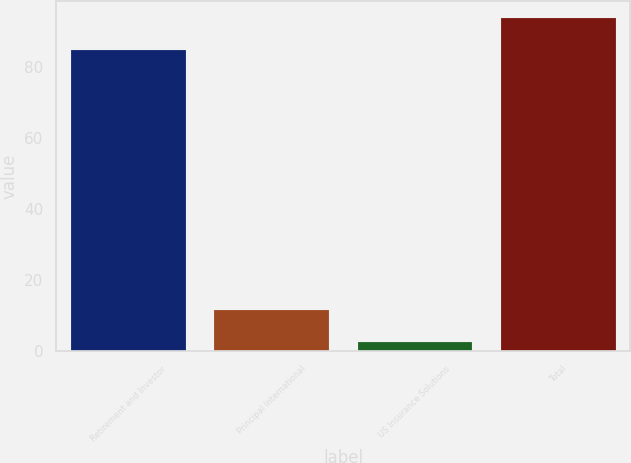Convert chart. <chart><loc_0><loc_0><loc_500><loc_500><bar_chart><fcel>Retirement and Investor<fcel>Principal International<fcel>US Insurance Solutions<fcel>Total<nl><fcel>84.8<fcel>11.51<fcel>2.5<fcel>93.81<nl></chart> 